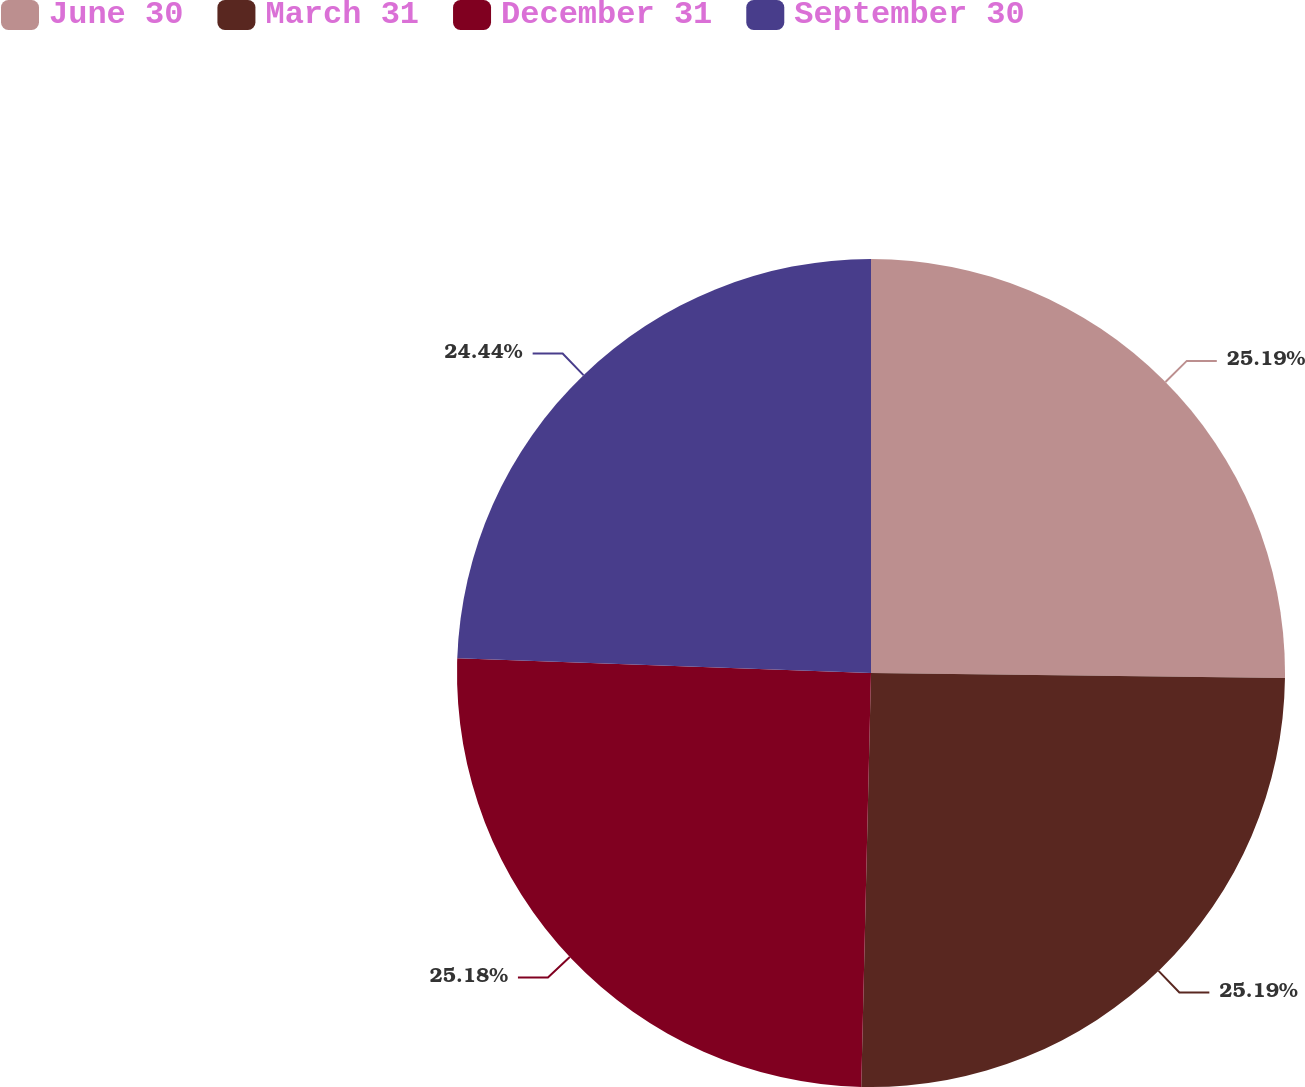Convert chart to OTSL. <chart><loc_0><loc_0><loc_500><loc_500><pie_chart><fcel>June 30<fcel>March 31<fcel>December 31<fcel>September 30<nl><fcel>25.19%<fcel>25.19%<fcel>25.19%<fcel>24.44%<nl></chart> 